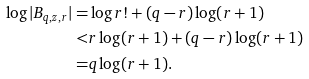Convert formula to latex. <formula><loc_0><loc_0><loc_500><loc_500>\log | B _ { q , z , r } | = & \log r ! + ( q - r ) \log ( r + 1 ) \\ < & r \log ( r + 1 ) + ( q - r ) \log ( r + 1 ) \\ = & q \log ( r + 1 ) .</formula> 